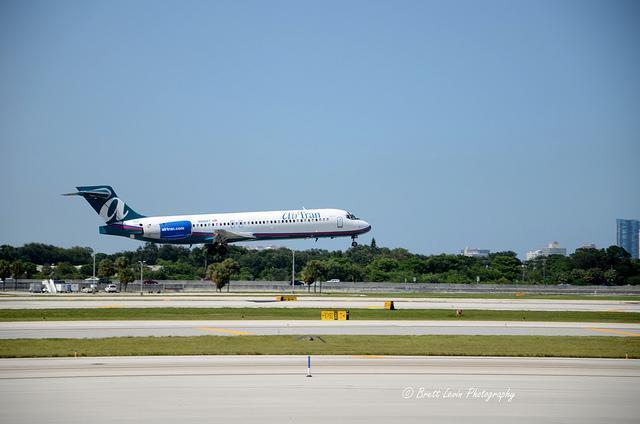How many planes are there?
Give a very brief answer. 1. How many girl goats are there?
Give a very brief answer. 0. 